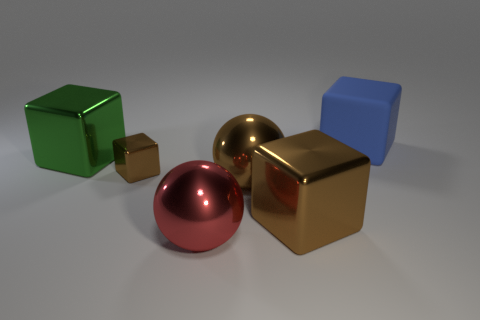Add 4 cyan objects. How many objects exist? 10 Subtract all cubes. How many objects are left? 2 Add 2 big shiny spheres. How many big shiny spheres are left? 4 Add 4 large blue rubber blocks. How many large blue rubber blocks exist? 5 Subtract 0 green cylinders. How many objects are left? 6 Subtract all spheres. Subtract all big green metal things. How many objects are left? 3 